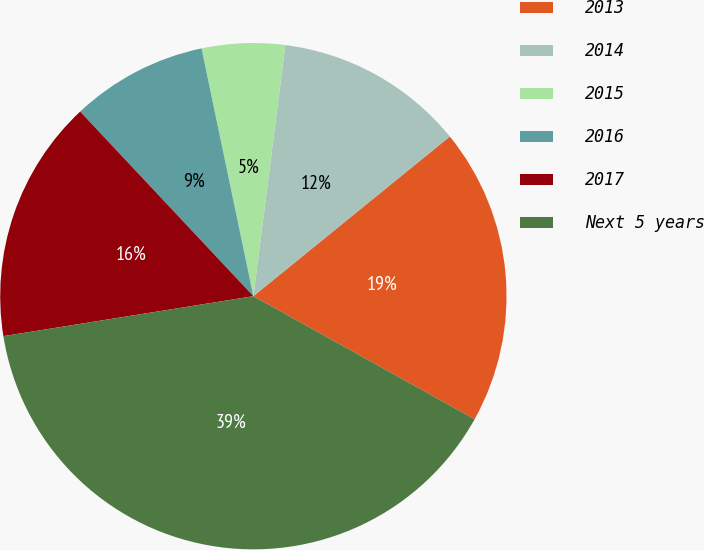Convert chart to OTSL. <chart><loc_0><loc_0><loc_500><loc_500><pie_chart><fcel>2013<fcel>2014<fcel>2015<fcel>2016<fcel>2017<fcel>Next 5 years<nl><fcel>18.94%<fcel>12.12%<fcel>5.3%<fcel>8.71%<fcel>15.53%<fcel>39.4%<nl></chart> 